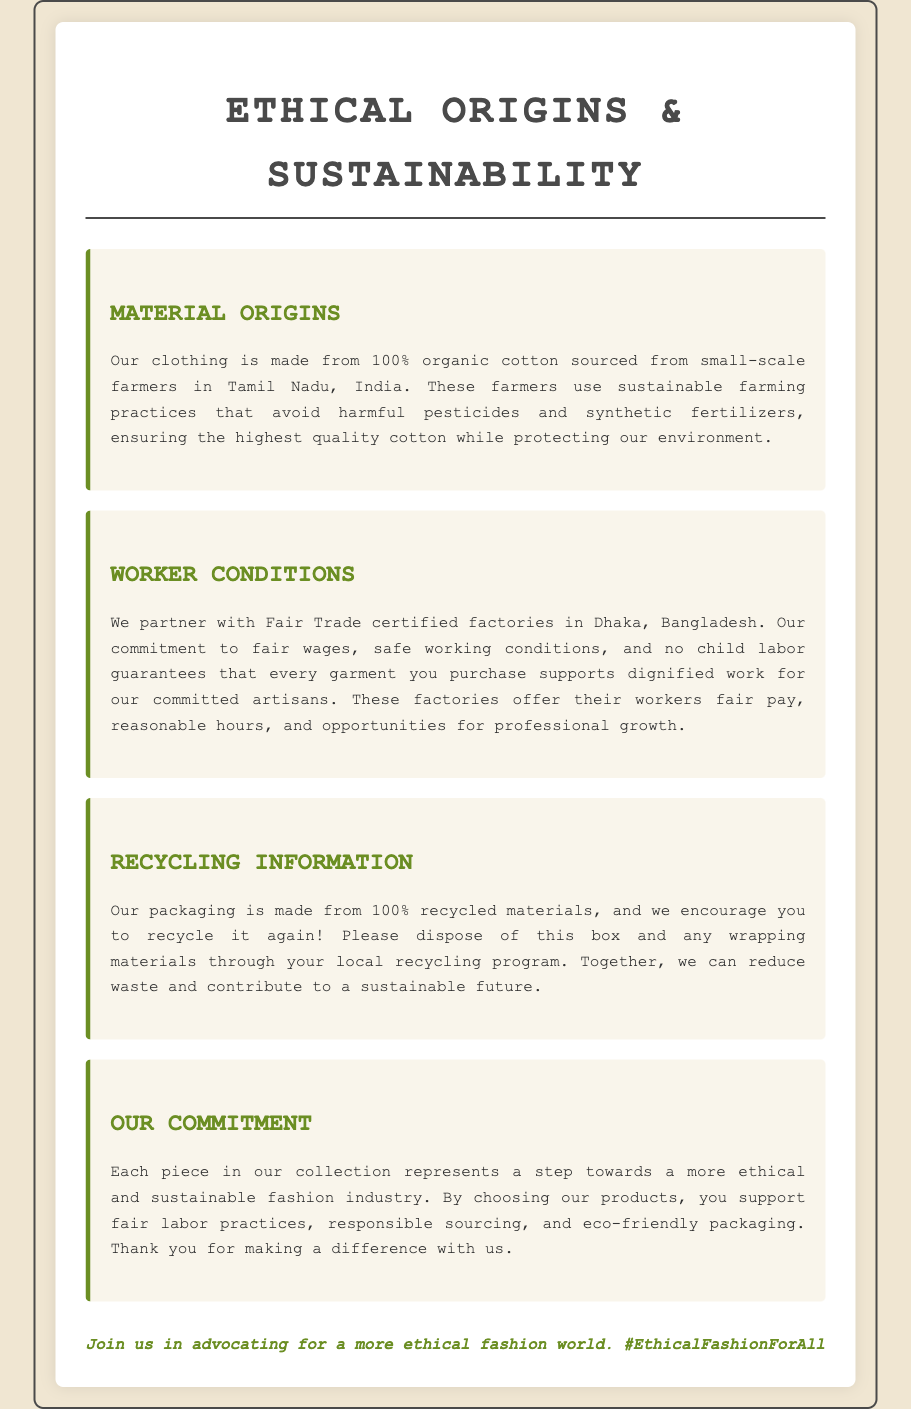What is the material used in the clothing? The document states that the clothing is made from 100% organic cotton.
Answer: 100% organic cotton Where are the materials sourced from? The document specifies that the materials are sourced from small-scale farmers in Tamil Nadu, India.
Answer: Tamil Nadu, India What certification do the factories have? The document mentions that the factories are Fair Trade certified.
Answer: Fair Trade certified What encourages recycling of the packaging? The document highlights that the packaging is made from 100% recycled materials and encourages recycling through local programs.
Answer: 100% recycled materials What aspect of worker welfare is guaranteed by the company? The document emphasizes fair wages, safe working conditions, and no child labor as guaranteed aspects for the workers.
Answer: fair wages, safe working conditions, and no child labor How does the company support workers? The document states that the company supports workers by providing fair pay, reasonable hours, and opportunities for professional growth.
Answer: fair pay, reasonable hours, and opportunities for professional growth What is the primary focus of the clothing line? The document indicates that the primary focus is on ethical and sustainable fashion.
Answer: ethical and sustainable fashion What does the company encourage customers to do with the packaging? The document encourages customers to dispose of the packaging through their local recycling program.
Answer: dispose of the packaging through local recycling program 